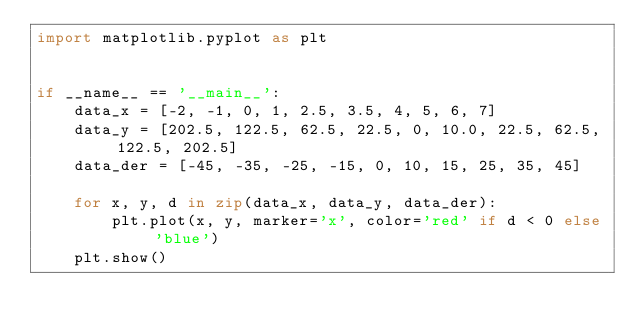Convert code to text. <code><loc_0><loc_0><loc_500><loc_500><_Python_>import matplotlib.pyplot as plt


if __name__ == '__main__':
	data_x = [-2, -1, 0, 1, 2.5, 3.5, 4, 5, 6, 7]
	data_y = [202.5, 122.5, 62.5, 22.5, 0, 10.0, 22.5, 62.5, 122.5, 202.5]
	data_der = [-45, -35, -25, -15, 0, 10, 15, 25, 35, 45]

	for x, y, d in zip(data_x, data_y, data_der):
		plt.plot(x, y, marker='x', color='red' if d < 0 else 'blue')
	plt.show()
</code> 